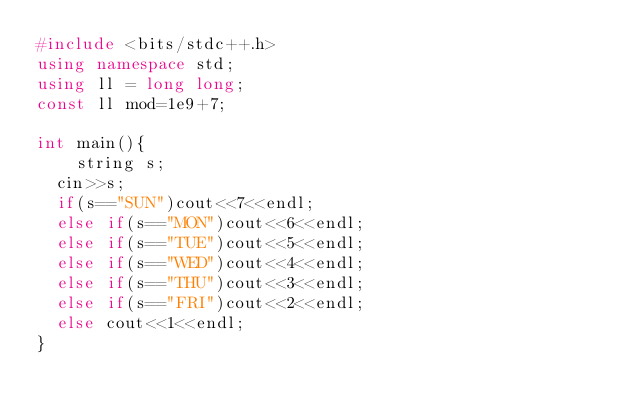Convert code to text. <code><loc_0><loc_0><loc_500><loc_500><_C++_>#include <bits/stdc++.h>
using namespace std;
using ll = long long;
const ll mod=1e9+7;

int main(){
    string s;
	cin>>s;
	if(s=="SUN")cout<<7<<endl;
	else if(s=="MON")cout<<6<<endl;
	else if(s=="TUE")cout<<5<<endl;
	else if(s=="WED")cout<<4<<endl;
	else if(s=="THU")cout<<3<<endl;
	else if(s=="FRI")cout<<2<<endl;
	else cout<<1<<endl;
}</code> 